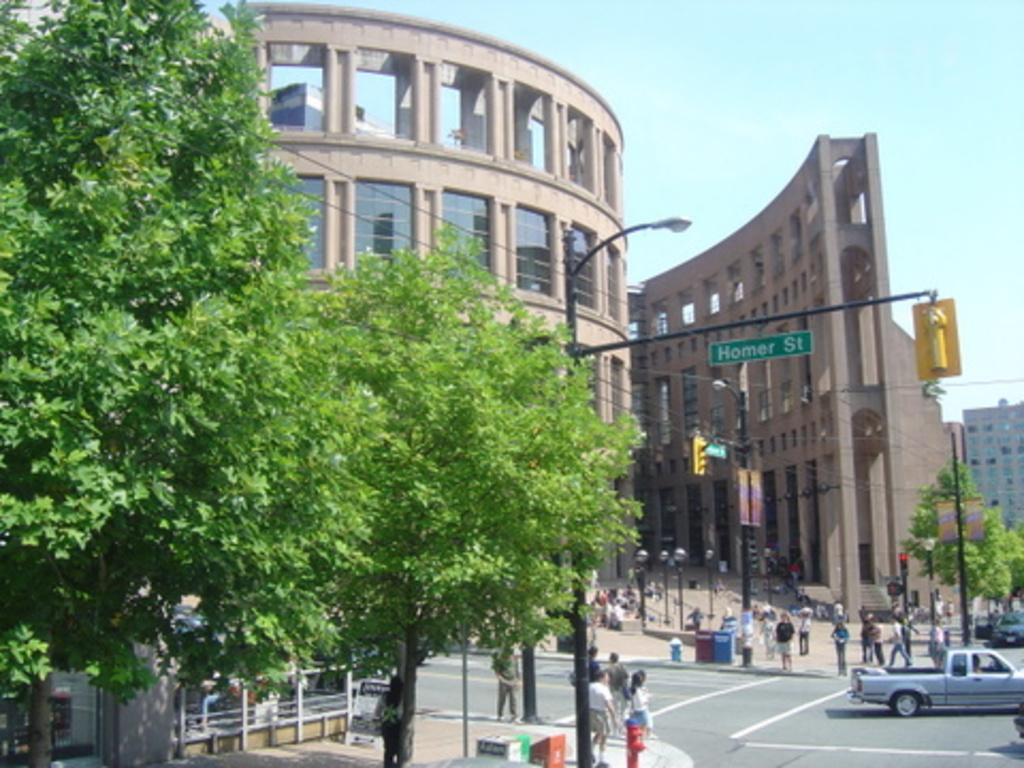Describe this image in one or two sentences. In this picture there are buildings and trees and there are street lights and there is a board on the pole and there is text on the board and there are vehicles on the road and there are group of people. In the foreground there is a fire hydrant and there are objects on the footpath. At the top there is sky. At the bottom there is a road. 